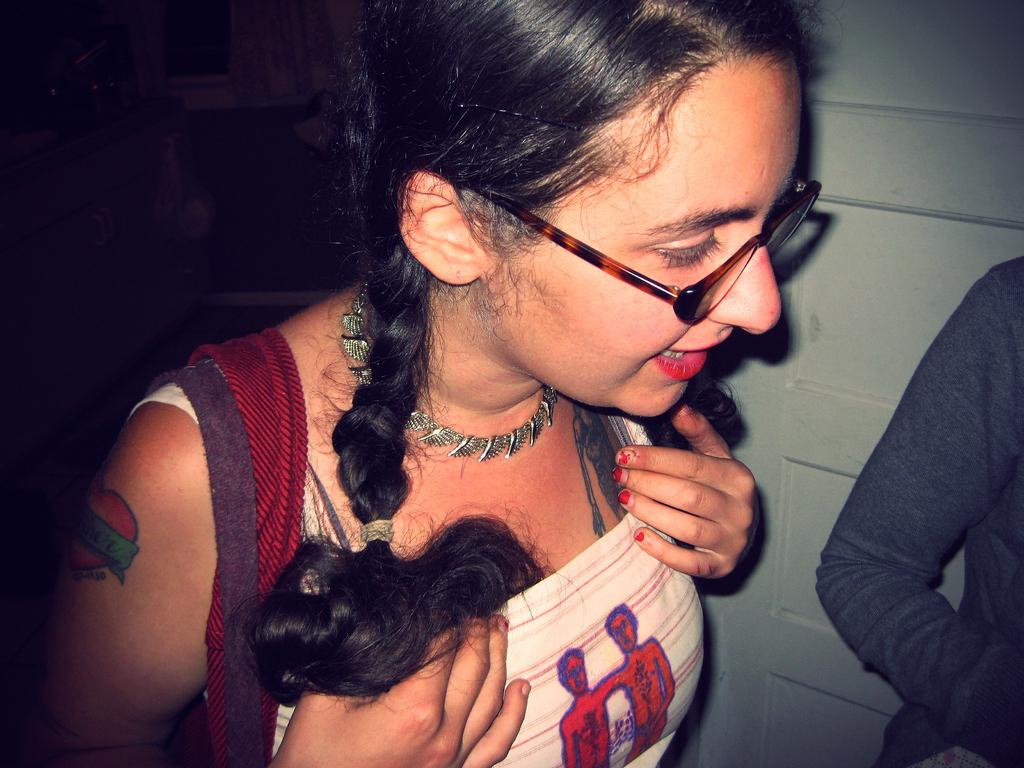How many people are in the image? There are two persons standing in the image. What is the color of the dress worn by one of the persons? One person is wearing a cream and red color dress. What is the color of the background wall in the image? The background wall is in light gray color. Can you see a stream flowing in the background of the image? There is no stream visible in the background of the image; it features a light gray wall. 